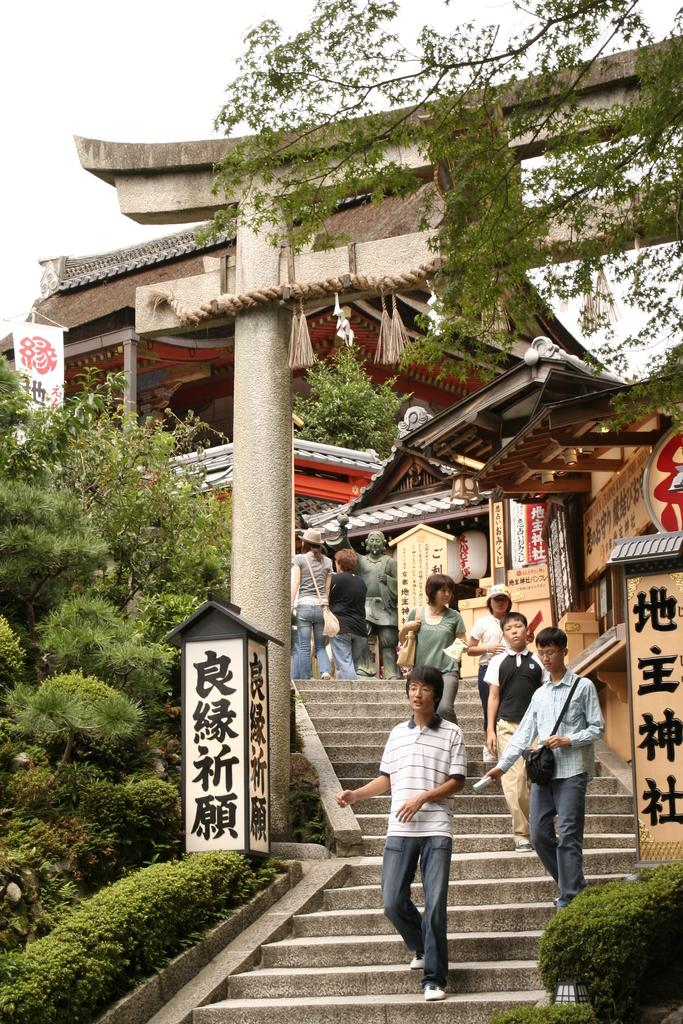How many people are in the image? There is a group of people in the image. What are the people doing in the image? The people are walking on stairs. What can be seen in the background of the image? There are stalls and trees in the background of the image. What color are the stalls in the image? The stalls are cream-colored. What color are the trees in the image? The trees are green. What is visible in the background of the image? The sky is visible in the background of the image. What color is the sky in the image? The sky is white in color. What type of bone is visible on the desk in the image? There is no bone or desk present in the image. How many trains can be seen in the image? There are no trains visible in the image. 